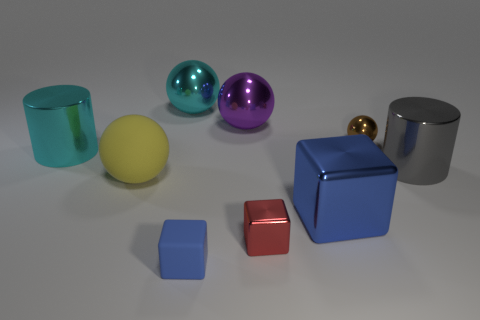Subtract all blue cubes. How many were subtracted if there are1blue cubes left? 1 Add 1 tiny gray shiny cubes. How many objects exist? 10 Subtract all cylinders. How many objects are left? 7 Subtract all tiny green rubber things. Subtract all brown spheres. How many objects are left? 8 Add 5 tiny rubber blocks. How many tiny rubber blocks are left? 6 Add 5 large blue matte things. How many large blue matte things exist? 5 Subtract 0 green cubes. How many objects are left? 9 